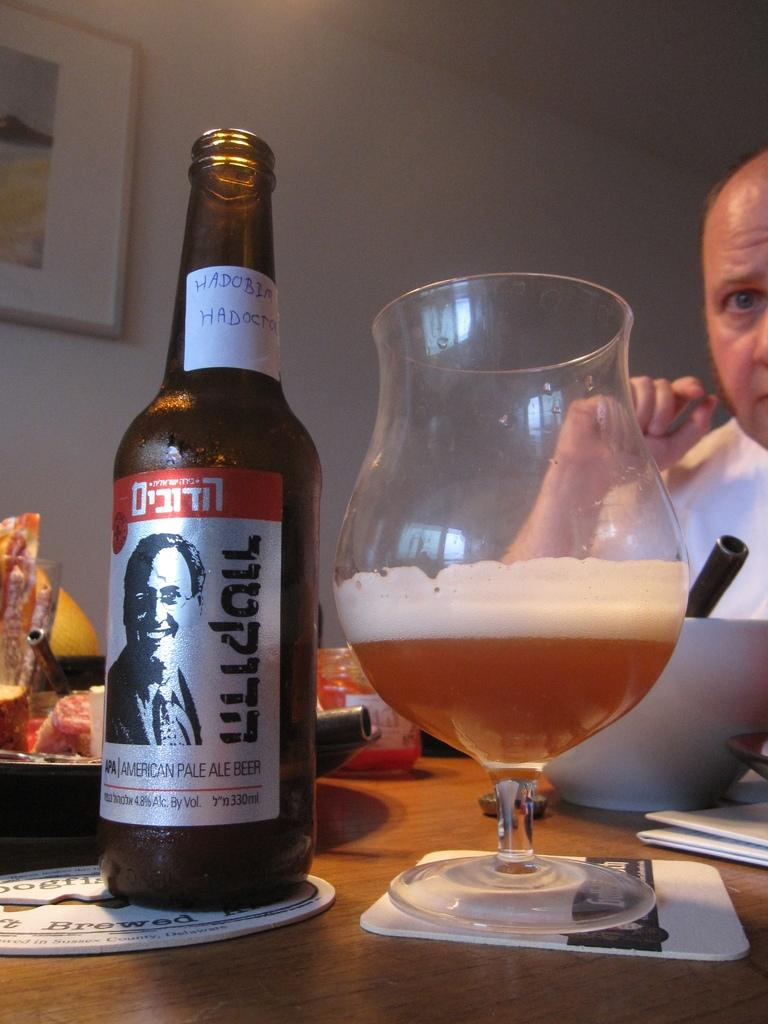Provide a one-sentence caption for the provided image. A man eating at a dinner table and drinking an American Pale Ale beer. 